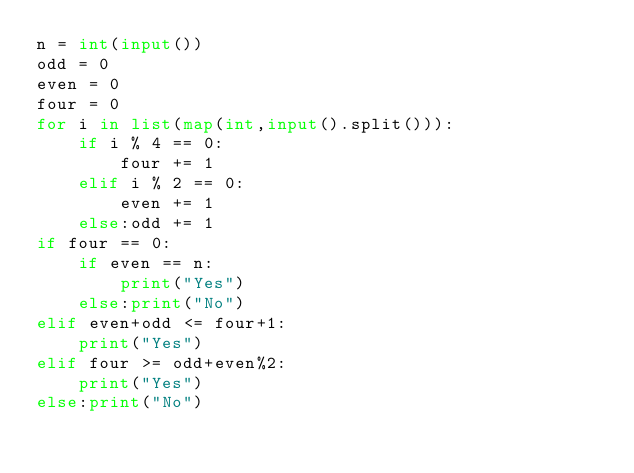<code> <loc_0><loc_0><loc_500><loc_500><_Python_>n = int(input())
odd = 0
even = 0
four = 0
for i in list(map(int,input().split())):
    if i % 4 == 0:
        four += 1
    elif i % 2 == 0:
        even += 1
    else:odd += 1
if four == 0:
    if even == n:
        print("Yes")
    else:print("No")
elif even+odd <= four+1:
    print("Yes")
elif four >= odd+even%2:
    print("Yes")
else:print("No")</code> 